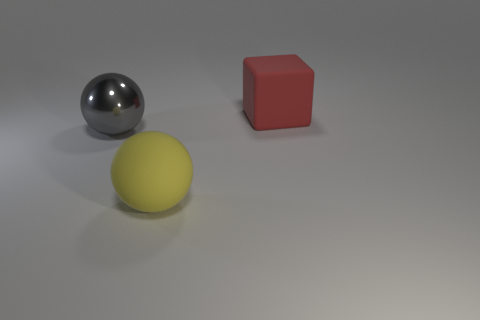Add 2 gray spheres. How many objects exist? 5 Subtract all balls. How many objects are left? 1 Subtract all gray balls. Subtract all small blue shiny objects. How many objects are left? 2 Add 3 spheres. How many spheres are left? 5 Add 2 large gray metallic spheres. How many large gray metallic spheres exist? 3 Subtract 0 yellow cylinders. How many objects are left? 3 